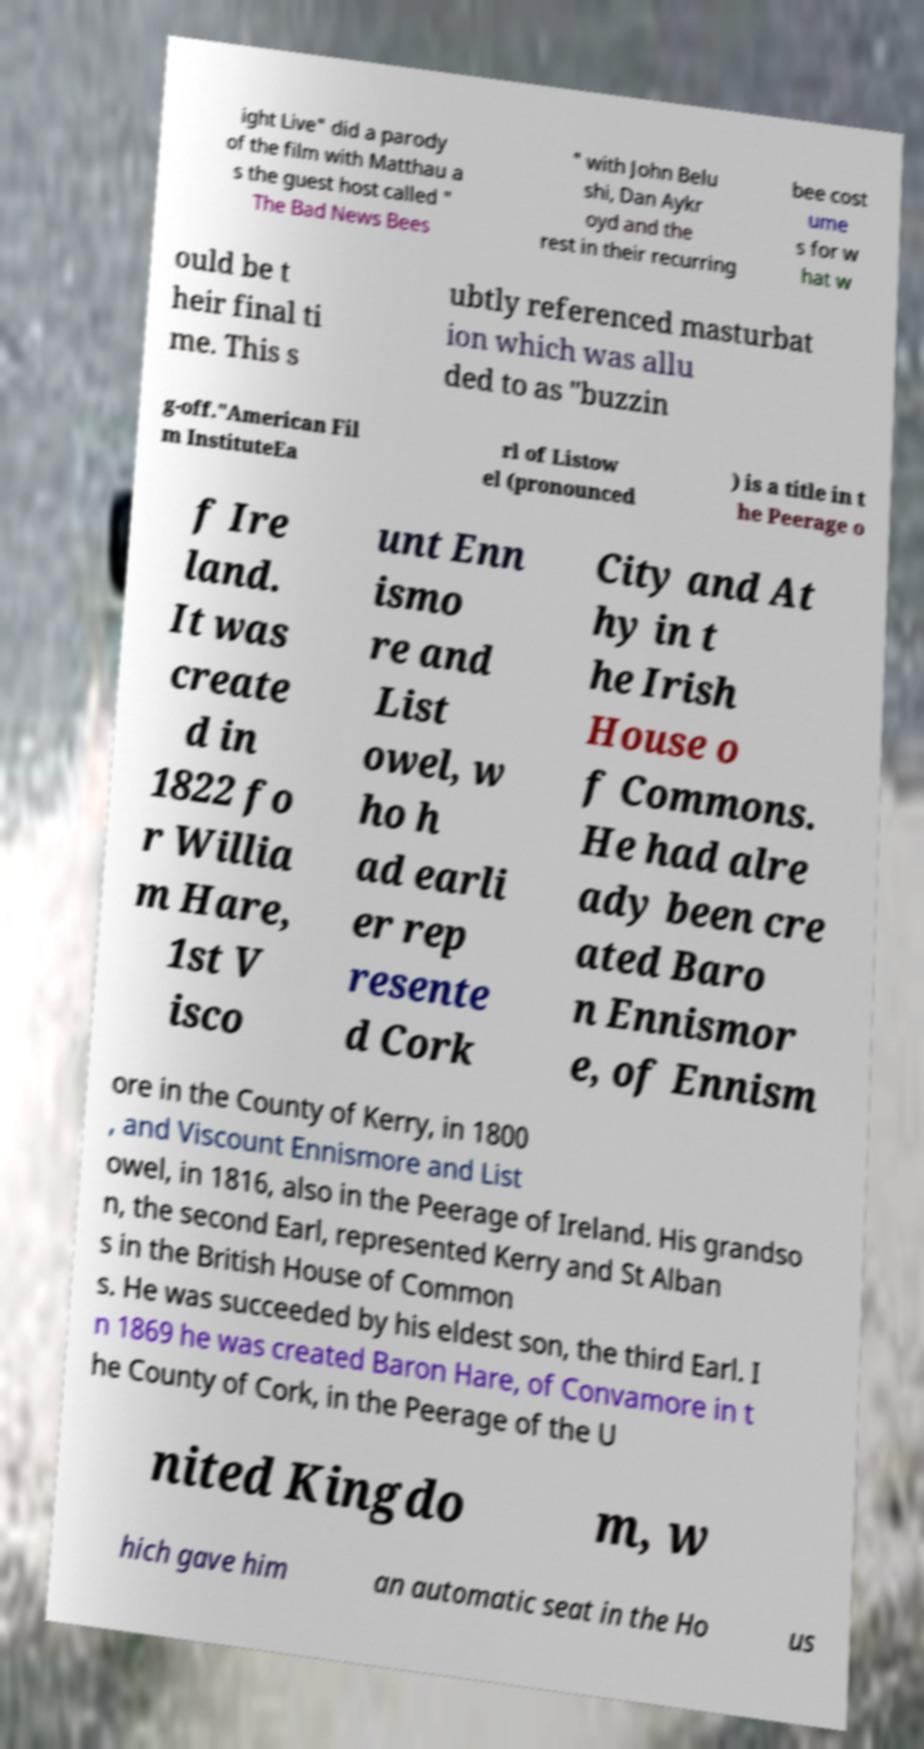Can you read and provide the text displayed in the image?This photo seems to have some interesting text. Can you extract and type it out for me? ight Live" did a parody of the film with Matthau a s the guest host called " The Bad News Bees " with John Belu shi, Dan Aykr oyd and the rest in their recurring bee cost ume s for w hat w ould be t heir final ti me. This s ubtly referenced masturbat ion which was allu ded to as "buzzin g-off."American Fil m InstituteEa rl of Listow el (pronounced ) is a title in t he Peerage o f Ire land. It was create d in 1822 fo r Willia m Hare, 1st V isco unt Enn ismo re and List owel, w ho h ad earli er rep resente d Cork City and At hy in t he Irish House o f Commons. He had alre ady been cre ated Baro n Ennismor e, of Ennism ore in the County of Kerry, in 1800 , and Viscount Ennismore and List owel, in 1816, also in the Peerage of Ireland. His grandso n, the second Earl, represented Kerry and St Alban s in the British House of Common s. He was succeeded by his eldest son, the third Earl. I n 1869 he was created Baron Hare, of Convamore in t he County of Cork, in the Peerage of the U nited Kingdo m, w hich gave him an automatic seat in the Ho us 